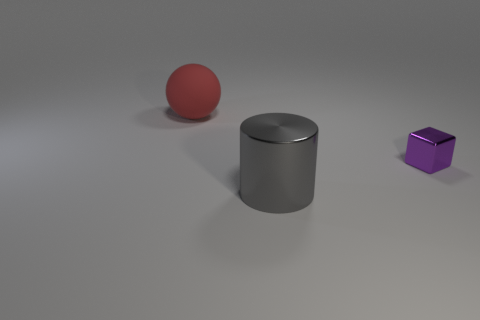Is there anything else that has the same color as the rubber ball?
Provide a short and direct response. No. Does the big red thing have the same material as the object that is right of the gray cylinder?
Your answer should be very brief. No. There is a large object right of the thing that is on the left side of the large shiny thing; what is its shape?
Your answer should be very brief. Cylinder. There is a thing that is behind the gray thing and on the right side of the big sphere; what shape is it?
Provide a short and direct response. Cube. How many objects are either big red matte spheres or objects on the right side of the large matte ball?
Keep it short and to the point. 3. Is there any other thing that is made of the same material as the cube?
Provide a short and direct response. Yes. There is a thing that is both on the left side of the cube and on the right side of the big rubber sphere; what material is it?
Make the answer very short. Metal. What color is the object on the left side of the shiny thing that is in front of the tiny purple thing?
Your answer should be compact. Red. Are there an equal number of red matte things that are on the left side of the red ball and big gray shiny cylinders?
Provide a succinct answer. No. Is there a red rubber object that has the same size as the ball?
Offer a terse response. No. 